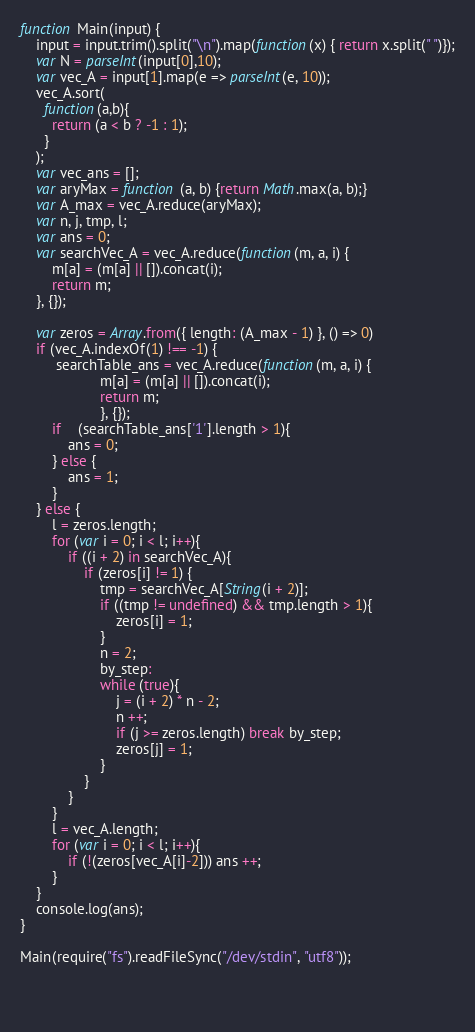<code> <loc_0><loc_0><loc_500><loc_500><_JavaScript_>function Main(input) {
    input = input.trim().split("\n").map(function(x) { return x.split(" ")});
    var N = parseInt(input[0],10);
    var vec_A = input[1].map(e => parseInt(e, 10));
    vec_A.sort(
	  function(a,b){
	    return (a < b ? -1 : 1);
	  }
	);
    var vec_ans = [];
    var aryMax = function (a, b) {return Math.max(a, b);}
    var A_max = vec_A.reduce(aryMax);
    var n, j, tmp, l;
    var ans = 0;
    var searchVec_A = vec_A.reduce(function(m, a, i) {
  		m[a] = (m[a] || []).concat(i);
  		return m;
	}, {});

    var zeros = Array.from({ length: (A_max - 1) }, () => 0)
	if (vec_A.indexOf(1) !== -1) {
		 searchTable_ans = vec_A.reduce(function(m, a, i) {
					m[a] = (m[a] || []).concat(i);
					return m;
					}, {});
        if	(searchTable_ans['1'].length > 1){
        	ans = 0;
        } else {
			ans = 1;
		}
	} else {
		l = zeros.length;
		for (var i = 0; i < l; i++){
			if ((i + 2) in searchVec_A){
				if (zeros[i] != 1) {
					tmp = searchVec_A[String(i + 2)];
					if ((tmp != undefined) && tmp.length > 1){
						zeros[i] = 1;
					}
					n = 2;
					by_step:
					while (true){
						j = (i + 2) * n - 2;
                      	n ++;
						if (j >= zeros.length) break by_step;
						zeros[j] = 1;
					}
				}
			}		
		}
		l = vec_A.length;
		for (var i = 0; i < l; i++){
			if (!(zeros[vec_A[i]-2])) ans ++;
		}
	}						
	console.log(ans);
}   

Main(require("fs").readFileSync("/dev/stdin", "utf8"));

 
	</code> 